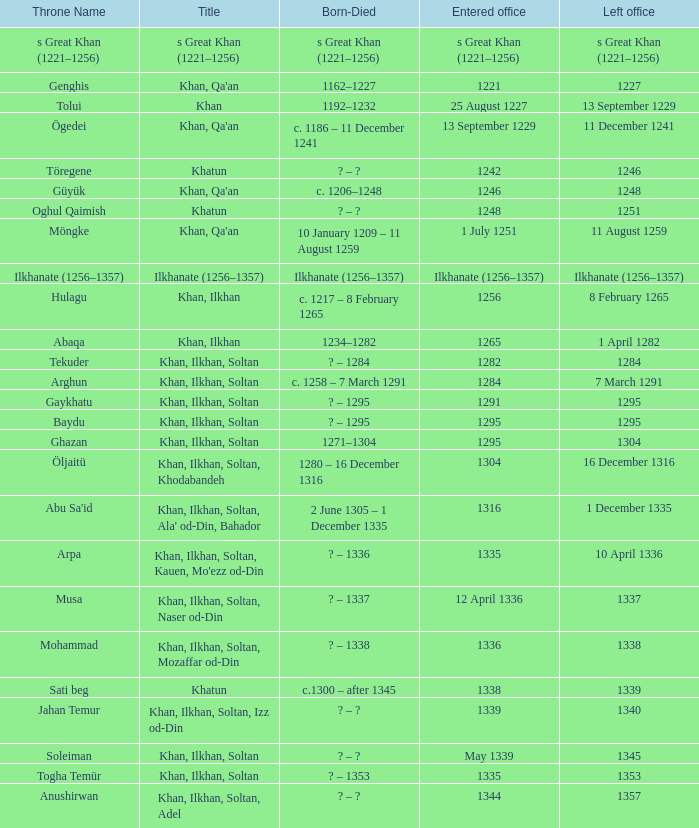What is the born-died that has office of 13 September 1229 as the entered? C. 1186 – 11 december 1241. 